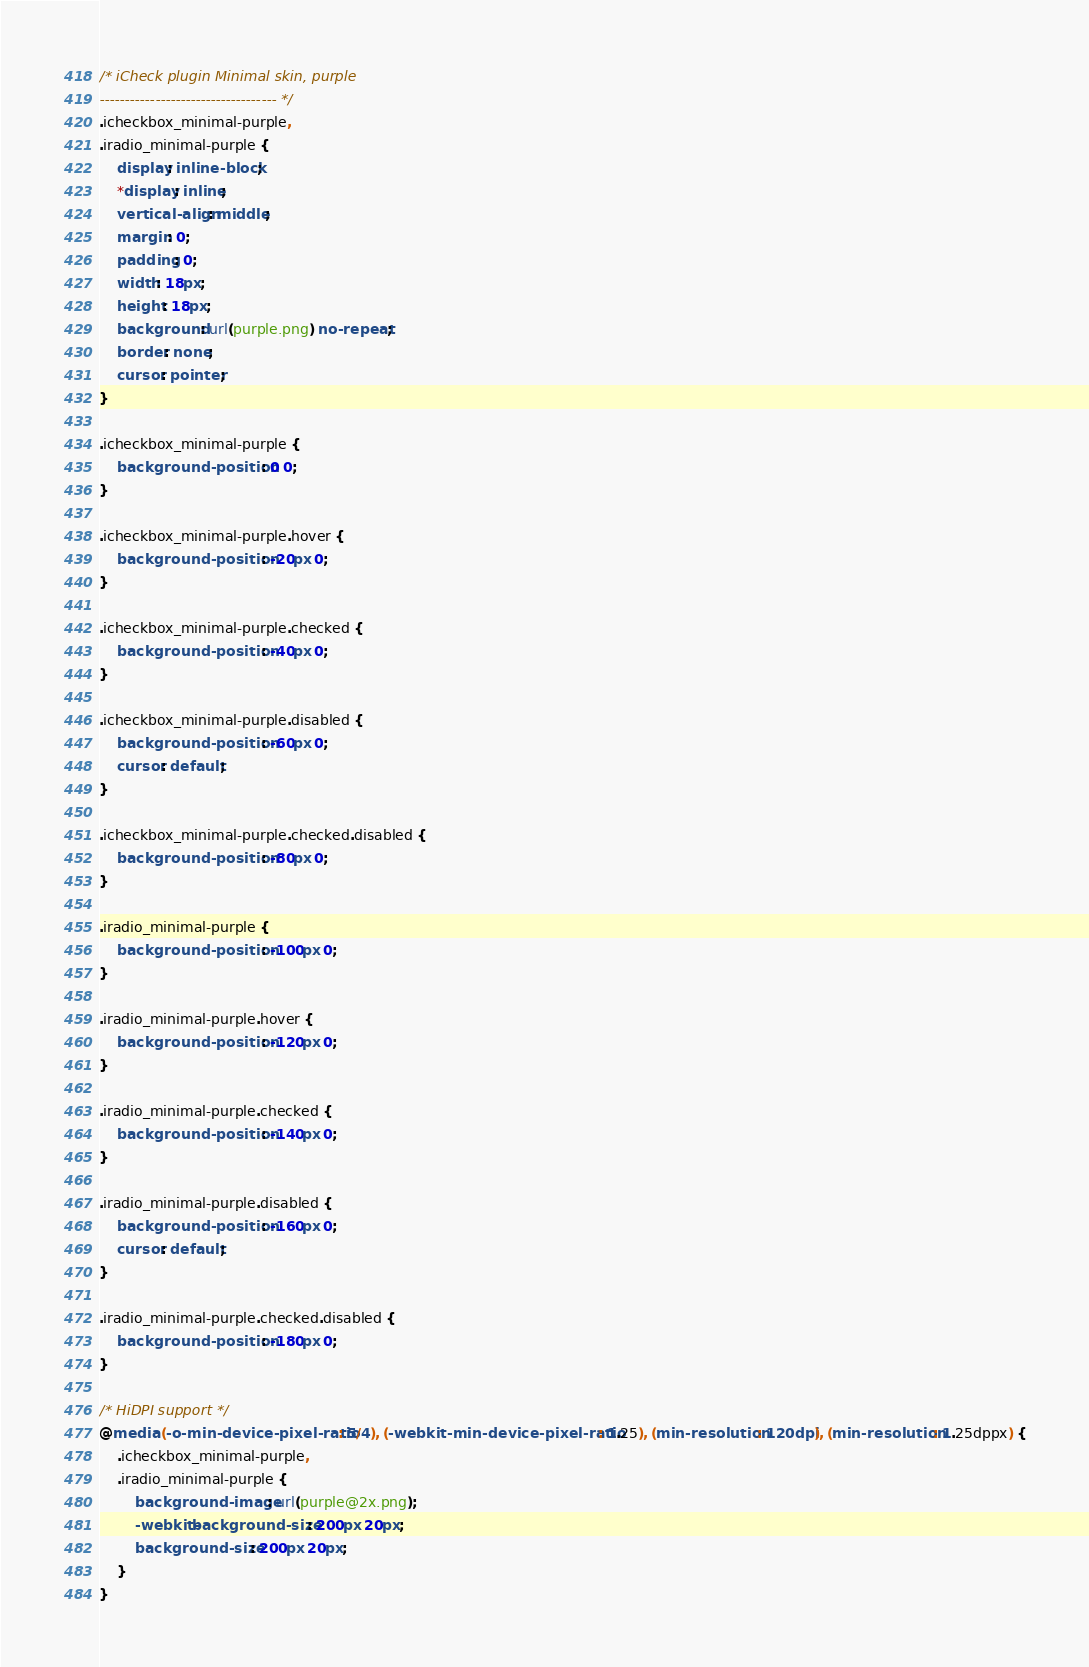Convert code to text. <code><loc_0><loc_0><loc_500><loc_500><_CSS_>/* iCheck plugin Minimal skin, purple
----------------------------------- */
.icheckbox_minimal-purple,
.iradio_minimal-purple {
    display: inline-block;
    *display: inline;
    vertical-align: middle;
    margin: 0;
    padding: 0;
    width: 18px;
    height: 18px;
    background: url(purple.png) no-repeat;
    border: none;
    cursor: pointer;
}

.icheckbox_minimal-purple {
    background-position: 0 0;
}

.icheckbox_minimal-purple.hover {
    background-position: -20px 0;
}

.icheckbox_minimal-purple.checked {
    background-position: -40px 0;
}

.icheckbox_minimal-purple.disabled {
    background-position: -60px 0;
    cursor: default;
}

.icheckbox_minimal-purple.checked.disabled {
    background-position: -80px 0;
}

.iradio_minimal-purple {
    background-position: -100px 0;
}

.iradio_minimal-purple.hover {
    background-position: -120px 0;
}

.iradio_minimal-purple.checked {
    background-position: -140px 0;
}

.iradio_minimal-purple.disabled {
    background-position: -160px 0;
    cursor: default;
}

.iradio_minimal-purple.checked.disabled {
    background-position: -180px 0;
}

/* HiDPI support */
@media (-o-min-device-pixel-ratio: 5/4), (-webkit-min-device-pixel-ratio: 1.25), (min-resolution: 120dpi), (min-resolution: 1.25dppx) {
    .icheckbox_minimal-purple,
    .iradio_minimal-purple {
        background-image: url(purple@2x.png);
        -webkit-background-size: 200px 20px;
        background-size: 200px 20px;
    }
}
</code> 